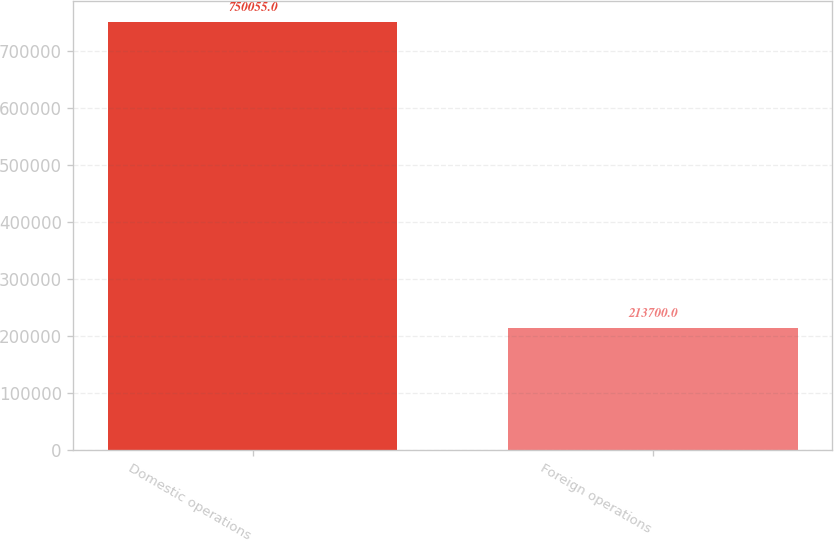Convert chart. <chart><loc_0><loc_0><loc_500><loc_500><bar_chart><fcel>Domestic operations<fcel>Foreign operations<nl><fcel>750055<fcel>213700<nl></chart> 